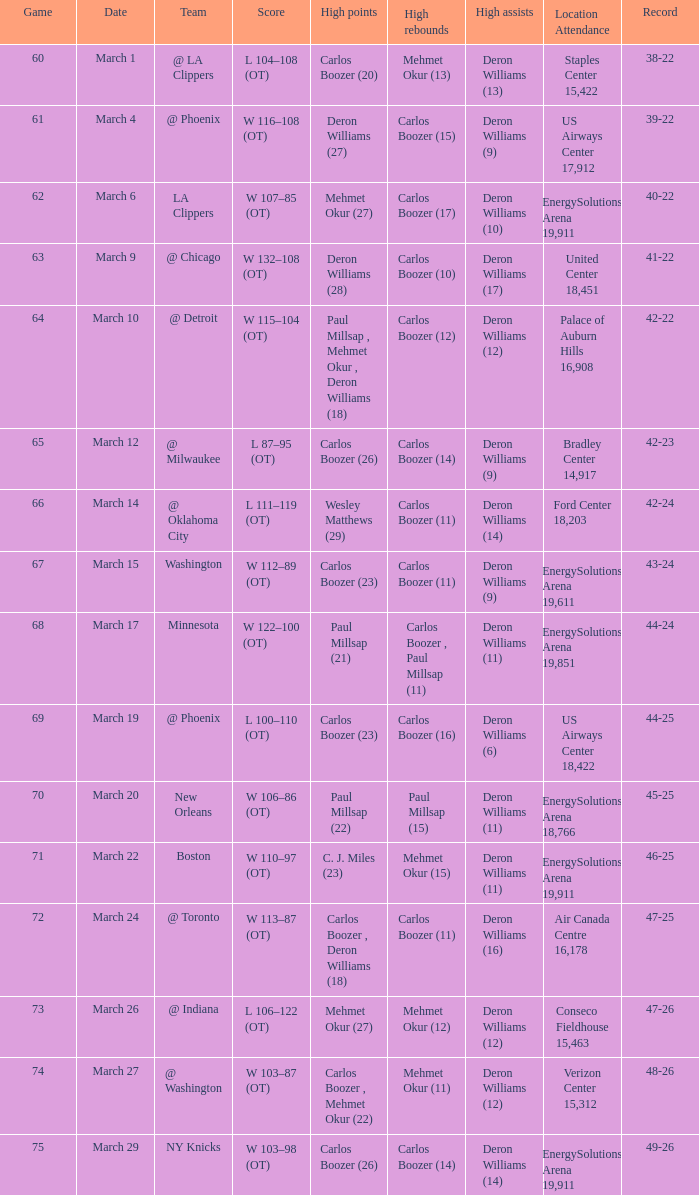How many players scored the most points in the game that had a 39-22 record? 1.0. Could you parse the entire table? {'header': ['Game', 'Date', 'Team', 'Score', 'High points', 'High rebounds', 'High assists', 'Location Attendance', 'Record'], 'rows': [['60', 'March 1', '@ LA Clippers', 'L 104–108 (OT)', 'Carlos Boozer (20)', 'Mehmet Okur (13)', 'Deron Williams (13)', 'Staples Center 15,422', '38-22'], ['61', 'March 4', '@ Phoenix', 'W 116–108 (OT)', 'Deron Williams (27)', 'Carlos Boozer (15)', 'Deron Williams (9)', 'US Airways Center 17,912', '39-22'], ['62', 'March 6', 'LA Clippers', 'W 107–85 (OT)', 'Mehmet Okur (27)', 'Carlos Boozer (17)', 'Deron Williams (10)', 'EnergySolutions Arena 19,911', '40-22'], ['63', 'March 9', '@ Chicago', 'W 132–108 (OT)', 'Deron Williams (28)', 'Carlos Boozer (10)', 'Deron Williams (17)', 'United Center 18,451', '41-22'], ['64', 'March 10', '@ Detroit', 'W 115–104 (OT)', 'Paul Millsap , Mehmet Okur , Deron Williams (18)', 'Carlos Boozer (12)', 'Deron Williams (12)', 'Palace of Auburn Hills 16,908', '42-22'], ['65', 'March 12', '@ Milwaukee', 'L 87–95 (OT)', 'Carlos Boozer (26)', 'Carlos Boozer (14)', 'Deron Williams (9)', 'Bradley Center 14,917', '42-23'], ['66', 'March 14', '@ Oklahoma City', 'L 111–119 (OT)', 'Wesley Matthews (29)', 'Carlos Boozer (11)', 'Deron Williams (14)', 'Ford Center 18,203', '42-24'], ['67', 'March 15', 'Washington', 'W 112–89 (OT)', 'Carlos Boozer (23)', 'Carlos Boozer (11)', 'Deron Williams (9)', 'EnergySolutions Arena 19,611', '43-24'], ['68', 'March 17', 'Minnesota', 'W 122–100 (OT)', 'Paul Millsap (21)', 'Carlos Boozer , Paul Millsap (11)', 'Deron Williams (11)', 'EnergySolutions Arena 19,851', '44-24'], ['69', 'March 19', '@ Phoenix', 'L 100–110 (OT)', 'Carlos Boozer (23)', 'Carlos Boozer (16)', 'Deron Williams (6)', 'US Airways Center 18,422', '44-25'], ['70', 'March 20', 'New Orleans', 'W 106–86 (OT)', 'Paul Millsap (22)', 'Paul Millsap (15)', 'Deron Williams (11)', 'EnergySolutions Arena 18,766', '45-25'], ['71', 'March 22', 'Boston', 'W 110–97 (OT)', 'C. J. Miles (23)', 'Mehmet Okur (15)', 'Deron Williams (11)', 'EnergySolutions Arena 19,911', '46-25'], ['72', 'March 24', '@ Toronto', 'W 113–87 (OT)', 'Carlos Boozer , Deron Williams (18)', 'Carlos Boozer (11)', 'Deron Williams (16)', 'Air Canada Centre 16,178', '47-25'], ['73', 'March 26', '@ Indiana', 'L 106–122 (OT)', 'Mehmet Okur (27)', 'Mehmet Okur (12)', 'Deron Williams (12)', 'Conseco Fieldhouse 15,463', '47-26'], ['74', 'March 27', '@ Washington', 'W 103–87 (OT)', 'Carlos Boozer , Mehmet Okur (22)', 'Mehmet Okur (11)', 'Deron Williams (12)', 'Verizon Center 15,312', '48-26'], ['75', 'March 29', 'NY Knicks', 'W 103–98 (OT)', 'Carlos Boozer (26)', 'Carlos Boozer (14)', 'Deron Williams (14)', 'EnergySolutions Arena 19,911', '49-26']]} 